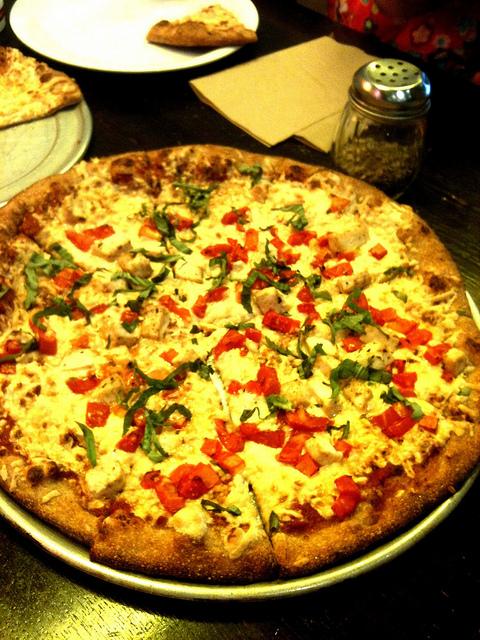IS the pizza sauce red or white?
Write a very short answer. White. How many toppings are on the pizza?
Keep it brief. 3. What is the table made of?
Write a very short answer. Wood. Is this pizza sprinkled with cheese?
Concise answer only. Yes. What color is the pan the pizza is on?
Concise answer only. Silver. Is this a vegetarian pizza?
Quick response, please. Yes. What spice is in the shaker?
Keep it brief. Oregano. 